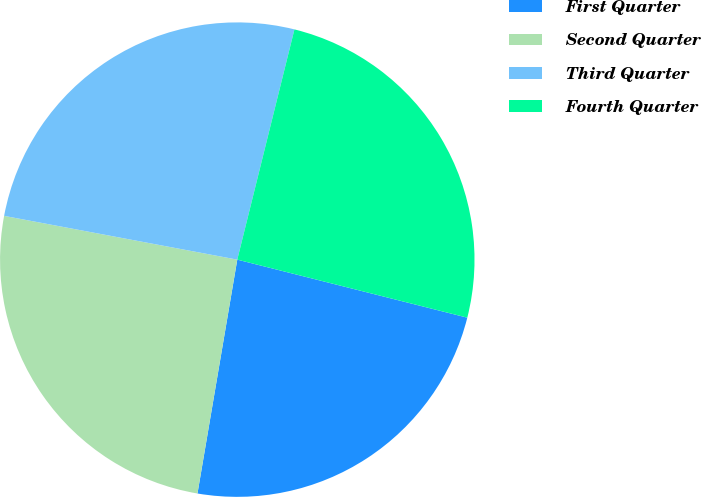Convert chart to OTSL. <chart><loc_0><loc_0><loc_500><loc_500><pie_chart><fcel>First Quarter<fcel>Second Quarter<fcel>Third Quarter<fcel>Fourth Quarter<nl><fcel>23.75%<fcel>25.27%<fcel>25.92%<fcel>25.06%<nl></chart> 